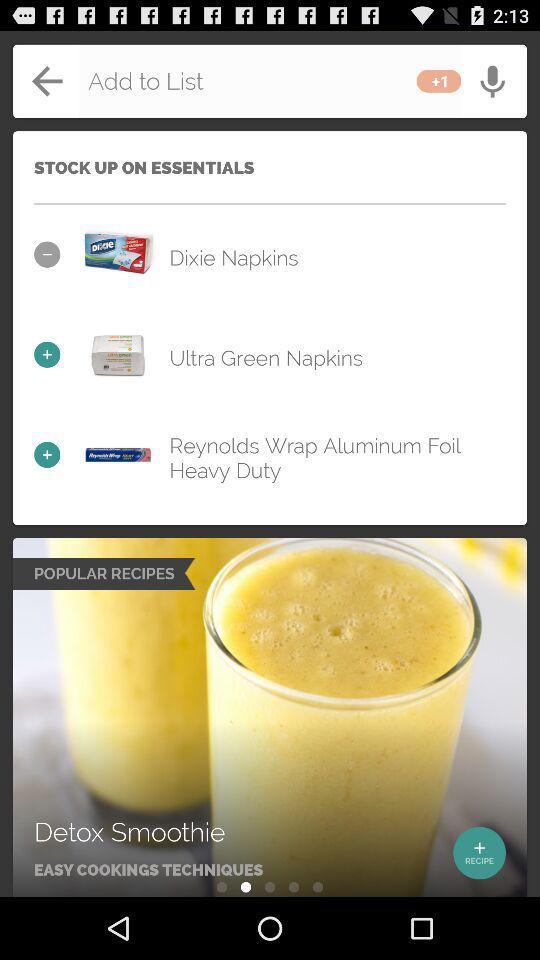What is the added item in "STOCK UP ON ESSENTIALS"? The added items in "STOCK UP ON ESSENTIALS" are "Ultra Green Napkins" and "Reynolds Wrap Aluminum Foil Heavy Duty". 